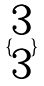Convert formula to latex. <formula><loc_0><loc_0><loc_500><loc_500>\{ \begin{matrix} 3 \\ 3 \end{matrix} \}</formula> 